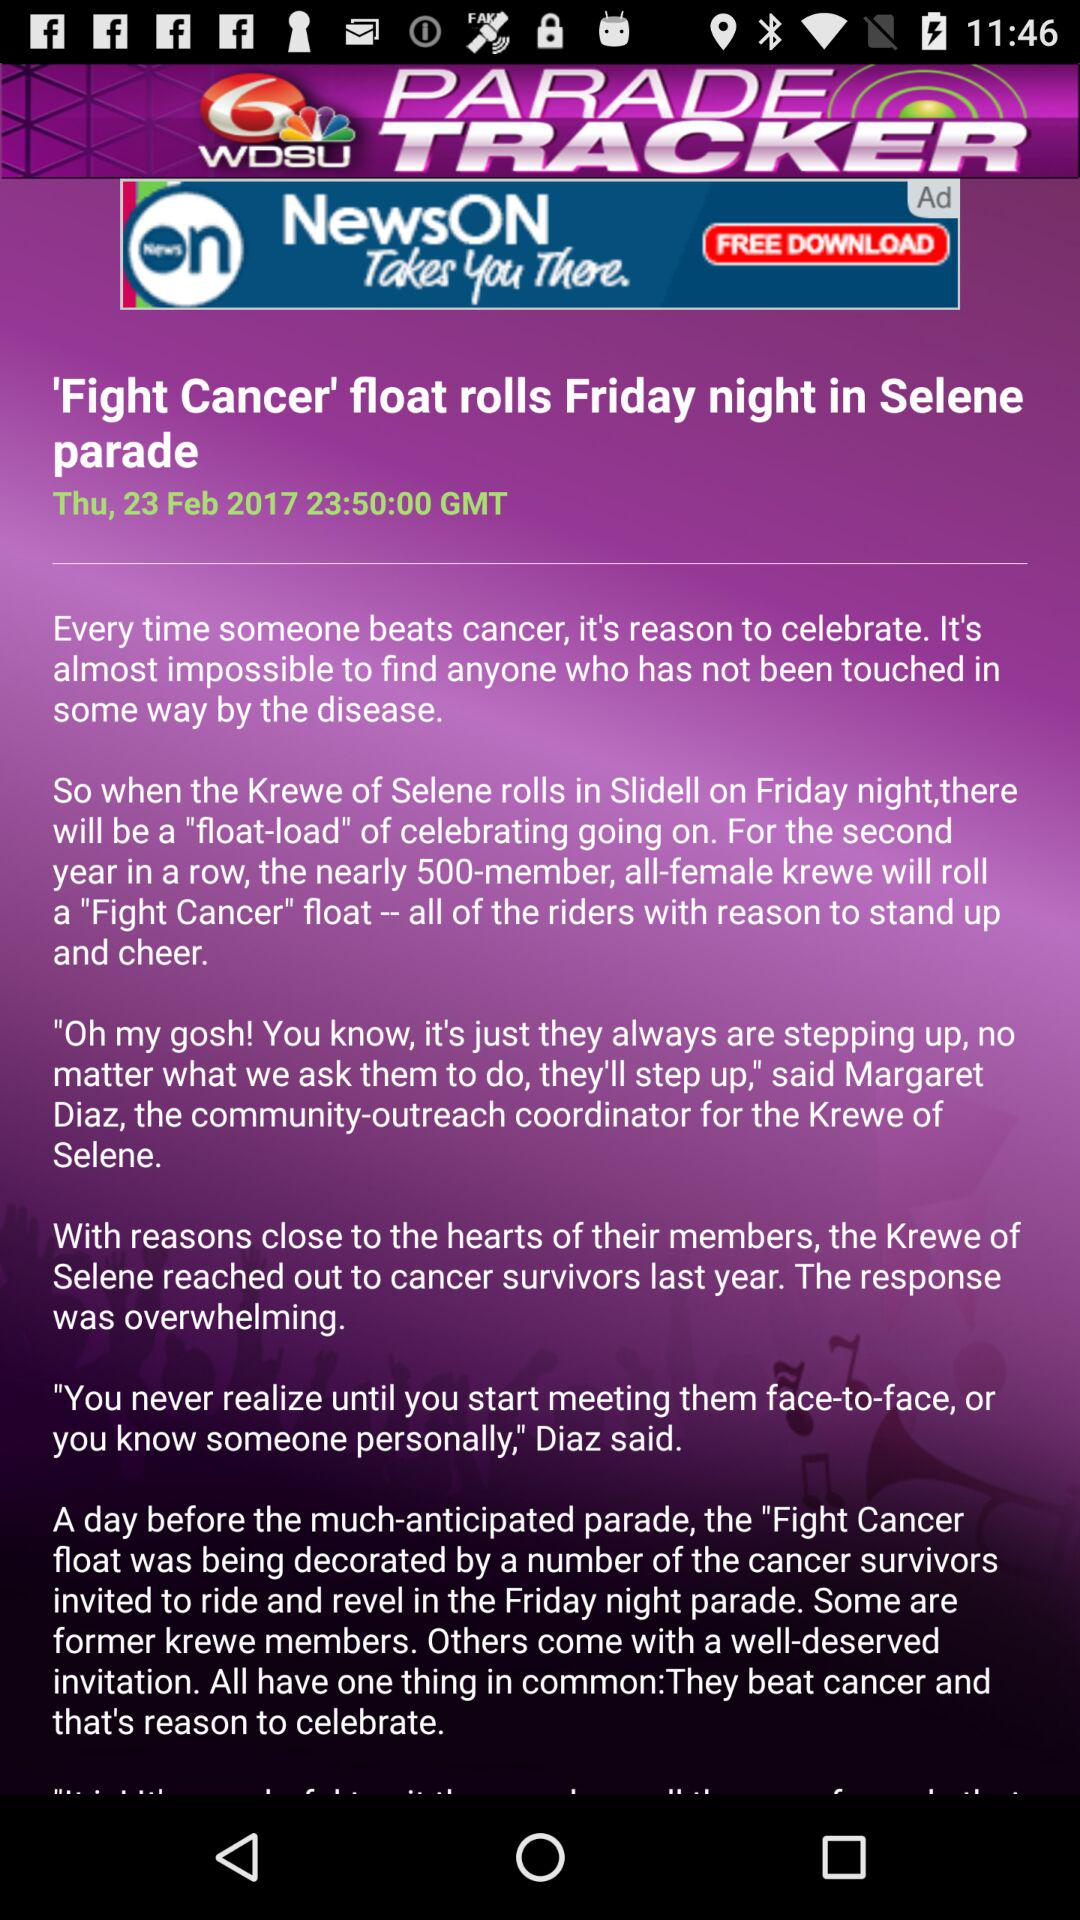When was the article posted? The article was posted on Thursday, February 23, 2017 at 23:50:00 GMT. 